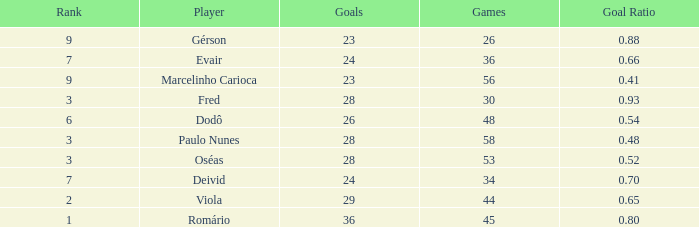How many goal ratios have rank of 2 with more than 44 games? 0.0. 